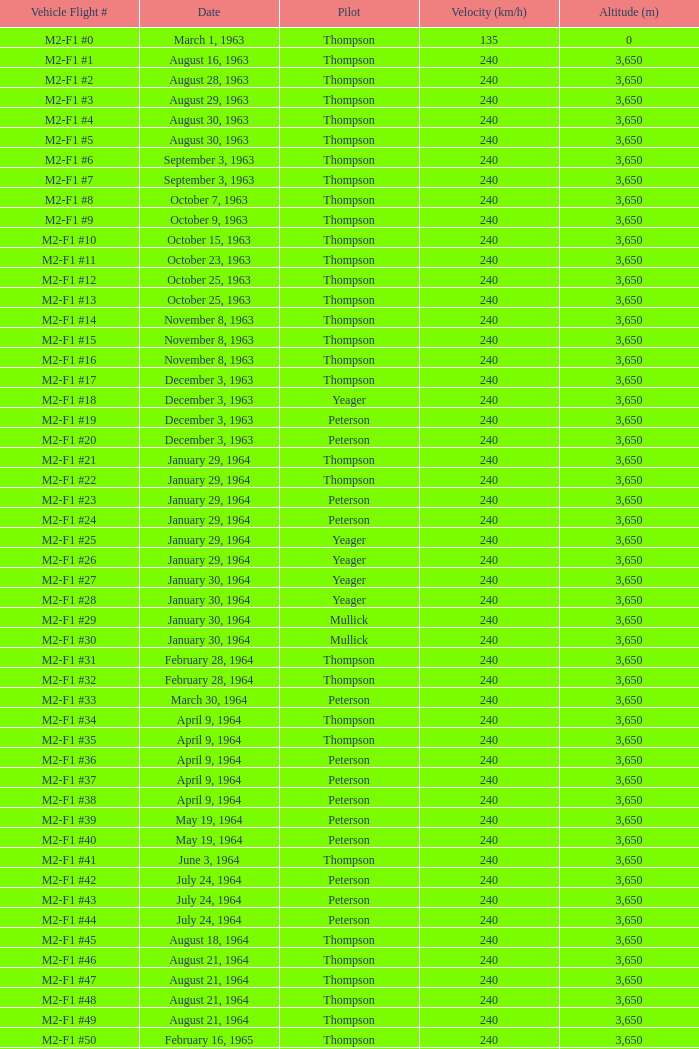On august 16, 1963, what is the speed? 240.0. 